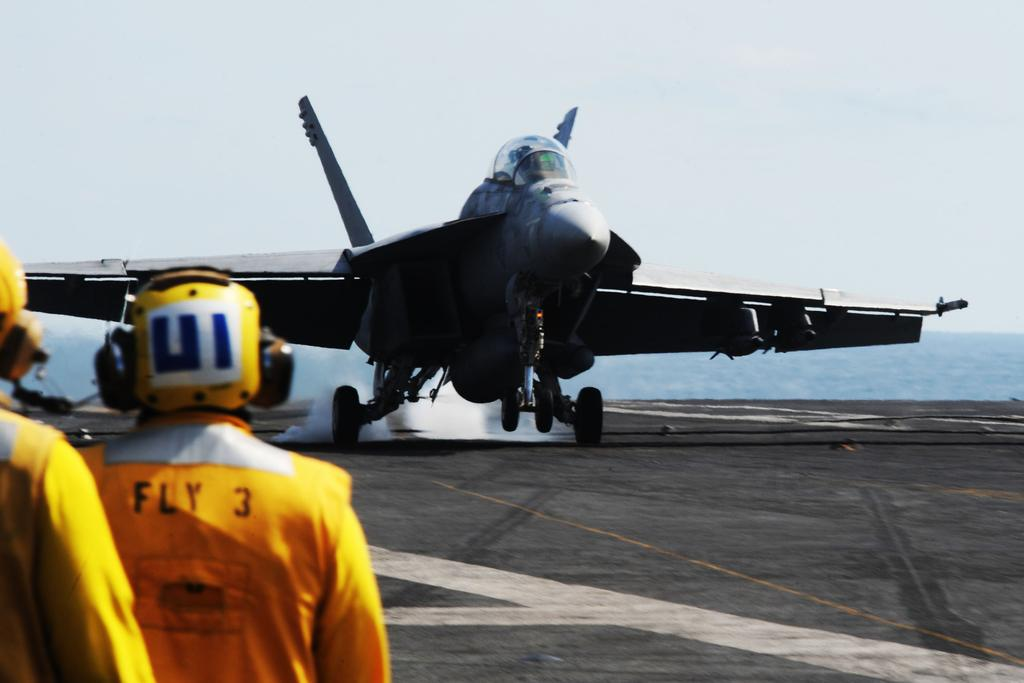<image>
Create a compact narrative representing the image presented. people wearing orange jumpsuits saying Fly 3 watch a plane land 